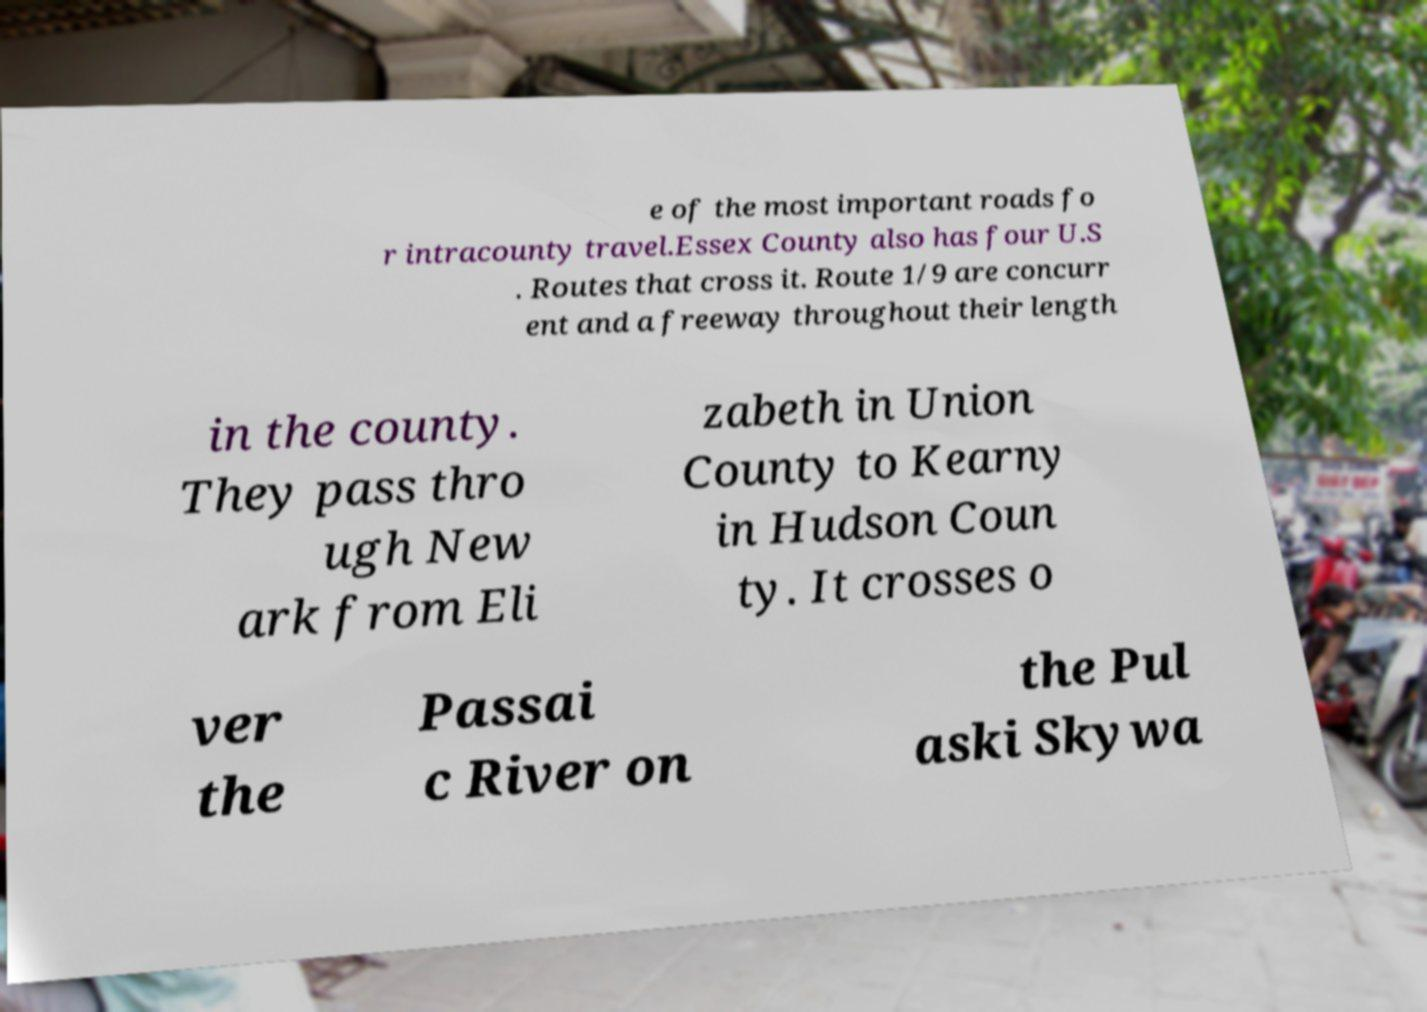I need the written content from this picture converted into text. Can you do that? e of the most important roads fo r intracounty travel.Essex County also has four U.S . Routes that cross it. Route 1/9 are concurr ent and a freeway throughout their length in the county. They pass thro ugh New ark from Eli zabeth in Union County to Kearny in Hudson Coun ty. It crosses o ver the Passai c River on the Pul aski Skywa 